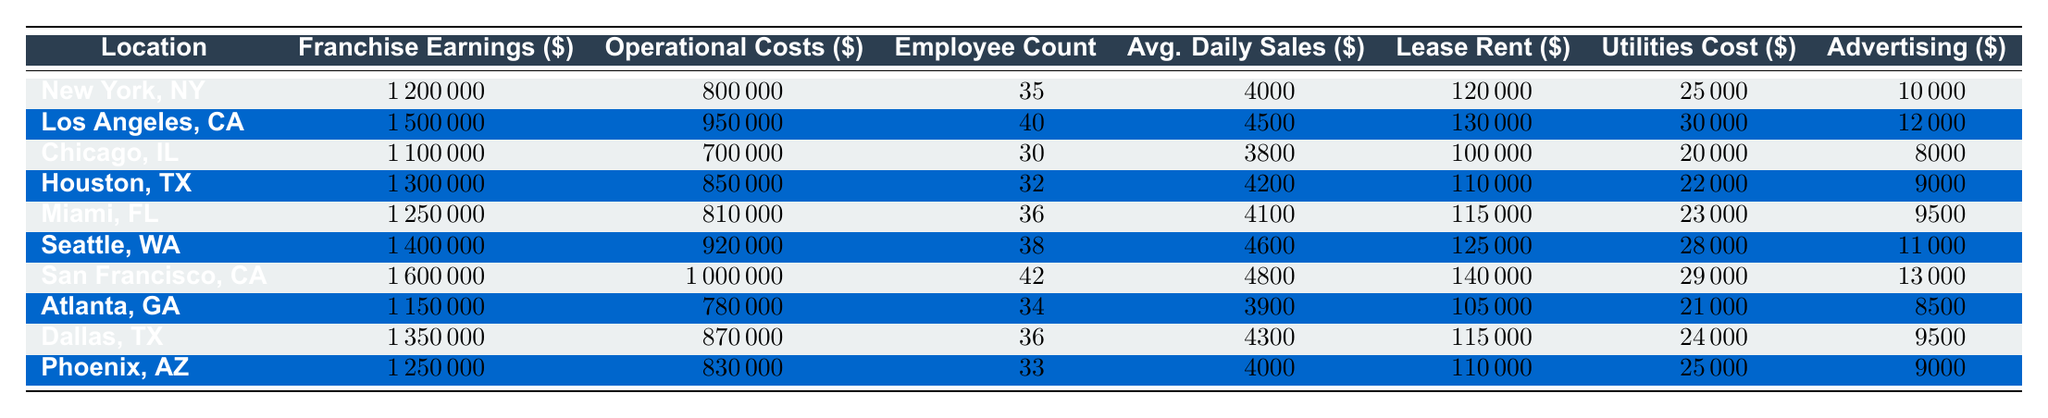What is the franchise earning of San Francisco, CA? The table provides the franchise earnings for each location. For San Francisco, the table shows that the earnings are 1,600,000 dollars.
Answer: 1,600,000 What are the operational costs of the franchise in Chicago, IL? Referring to the table, the operational costs specified for Chicago, IL amount to 700,000 dollars.
Answer: 700,000 Which location has the highest average daily sales? By comparing the average daily sales across all locations, San Francisco, CA has the highest average daily sales at 4,800 dollars.
Answer: San Francisco, CA What is the employee count for the Dallas, TX franchise? The employee count for the Dallas, TX franchise is explicitly listed in the table as 36.
Answer: 36 What is the difference between the franchise earnings in New York, NY and Atlanta, GA? The franchise earnings for New York, NY are 1,200,000 dollars, while for Atlanta, GA, it is 1,150,000 dollars. The difference is 1,200,000 - 1,150,000 = 50,000 dollars.
Answer: 50,000 What's the total operational costs for the franchises in Houston, TX and Miami, FL combined? The operational costs for Houston, TX are 850,000 dollars and for Miami, FL, it’s 810,000 dollars. Summing these gives 850,000 + 810,000 = 1,660,000 dollars.
Answer: 1,660,000 Are the advertising contributions in Seattle, WA greater than those in Chicago, IL? For Seattle, WA, the advertising contribution is 11,000 dollars and for Chicago, IL, it is 8,000 dollars. Since 11,000 is greater than 8,000, the statement is true.
Answer: Yes Which two locations have the highest operational costs, and what is their combined total? Analyzing the operational costs: the highest is San Francisco, CA (1,000,000 dollars) and the second-highest is Los Angeles, CA (950,000 dollars). Their combined total is 1,000,000 + 950,000 = 1,950,000 dollars.
Answer: 1,950,000 What is the average lease rent across all locations? Adding the lease rent values from all locations gives 1,200,000 + 1,300,000 + 1,000,000 + 1,100,000 + 1,150,000 + 1,250,000 + 1,400,000 + 1,050,000 + 1,150,000 + 1,100,000 = 11,500,000 dollars. There are 10 locations, so the average is 11,500,000 / 10 = 1,150,000 dollars.
Answer: 115,000 Which location has the lowest utilities cost, and what is that cost? The lowest utilities cost can be found by scanning the utilities costs for each location. The lowest is 20,000 dollars for Chicago, IL.
Answer: Chicago, IL - 20,000 